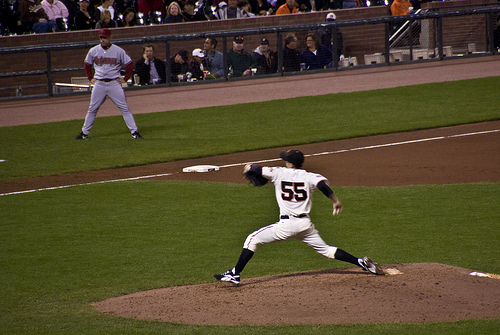Does the fence have a different color than the hat? No, the fence and the hat are both black. 